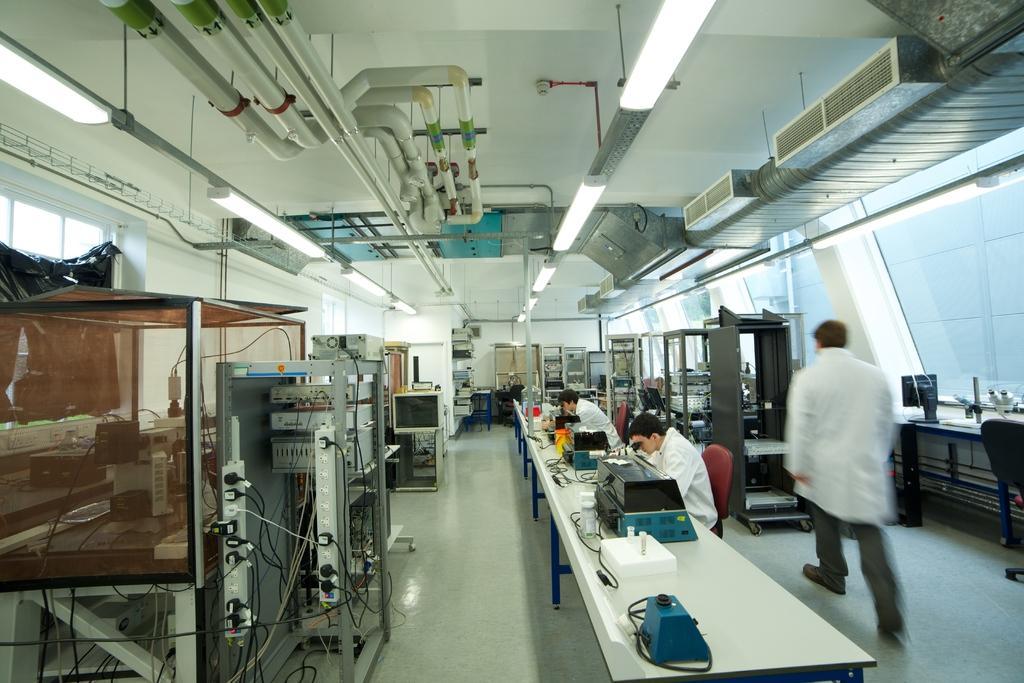In one or two sentences, can you explain what this image depicts? This is looking like inside of a lab. There are two person sitting and looking over the microscope. One person wearing a coat is walking. There is a table. There are wires and some machines. On the ceiling there are pipes and tube lights. 